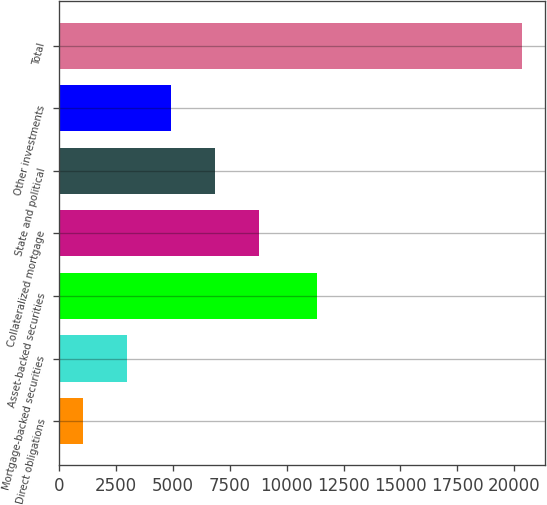Convert chart. <chart><loc_0><loc_0><loc_500><loc_500><bar_chart><fcel>Direct obligations<fcel>Mortgage-backed securities<fcel>Asset-backed securities<fcel>Collateralized mortgage<fcel>State and political<fcel>Other investments<fcel>Total<nl><fcel>1072<fcel>2998.3<fcel>11321<fcel>8777.2<fcel>6850.9<fcel>4924.6<fcel>20335<nl></chart> 